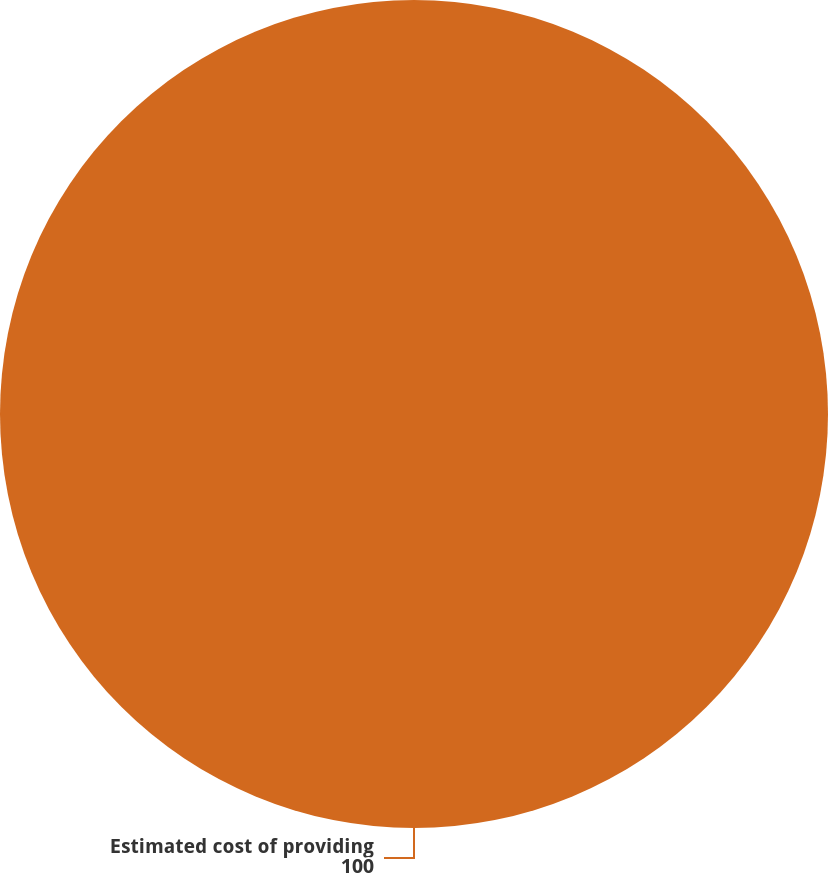<chart> <loc_0><loc_0><loc_500><loc_500><pie_chart><fcel>Estimated cost of providing<nl><fcel>100.0%<nl></chart> 